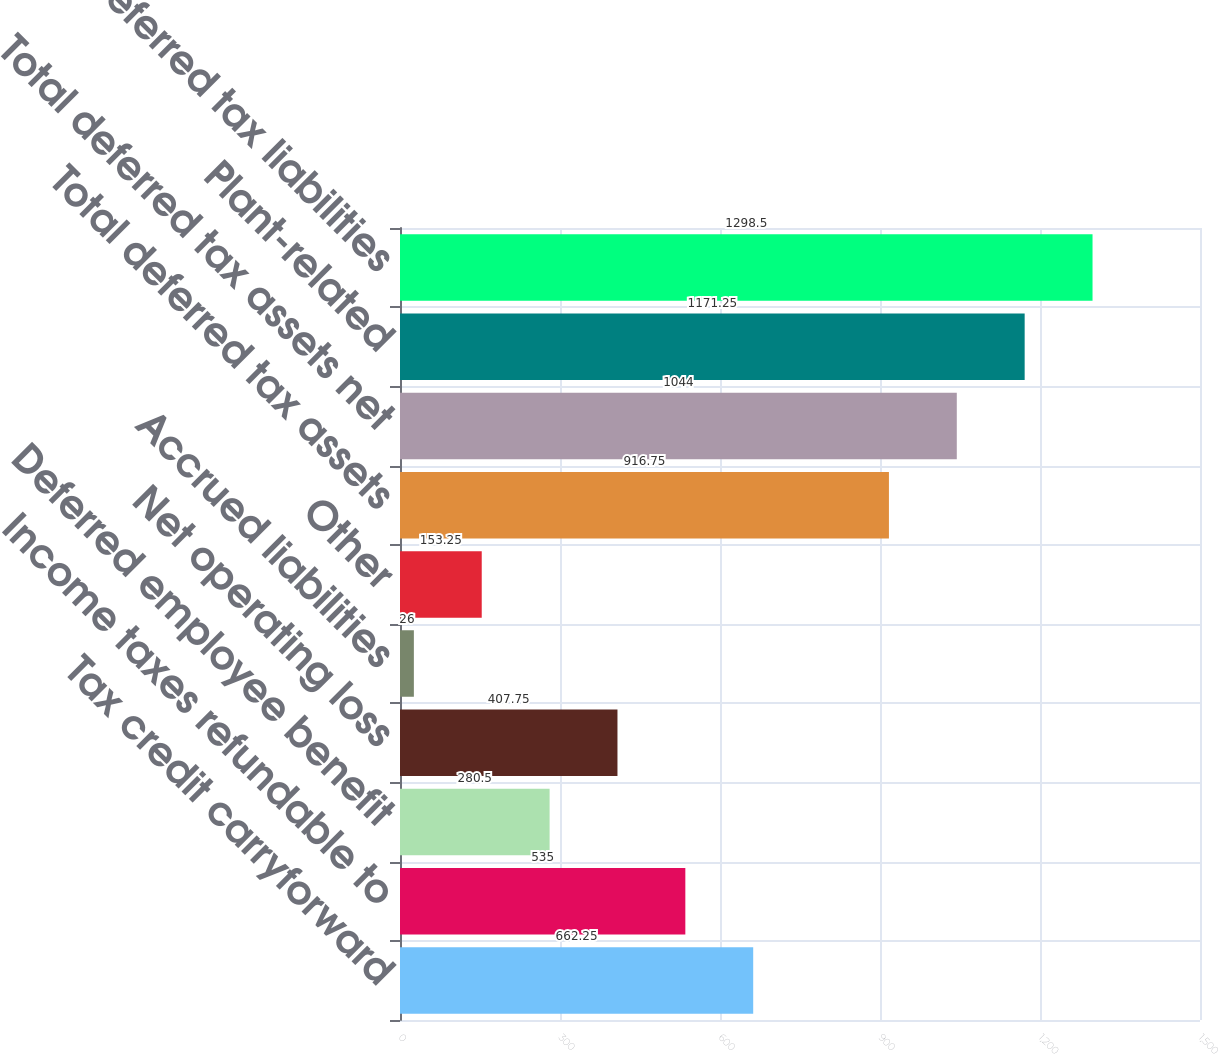Convert chart to OTSL. <chart><loc_0><loc_0><loc_500><loc_500><bar_chart><fcel>Tax credit carryforward<fcel>Income taxes refundable to<fcel>Deferred employee benefit<fcel>Net operating loss<fcel>Accrued liabilities<fcel>Other<fcel>Total deferred tax assets<fcel>Total deferred tax assets net<fcel>Plant-related<fcel>Total deferred tax liabilities<nl><fcel>662.25<fcel>535<fcel>280.5<fcel>407.75<fcel>26<fcel>153.25<fcel>916.75<fcel>1044<fcel>1171.25<fcel>1298.5<nl></chart> 